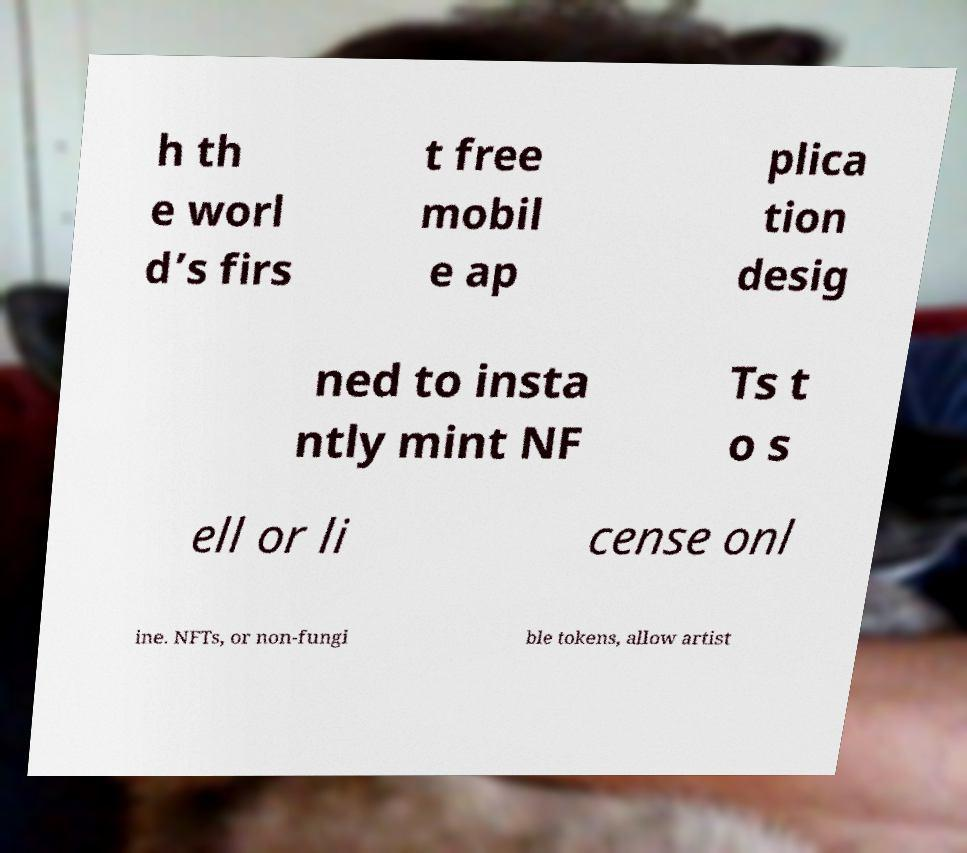What messages or text are displayed in this image? I need them in a readable, typed format. h th e worl d’s firs t free mobil e ap plica tion desig ned to insta ntly mint NF Ts t o s ell or li cense onl ine. NFTs, or non-fungi ble tokens, allow artist 